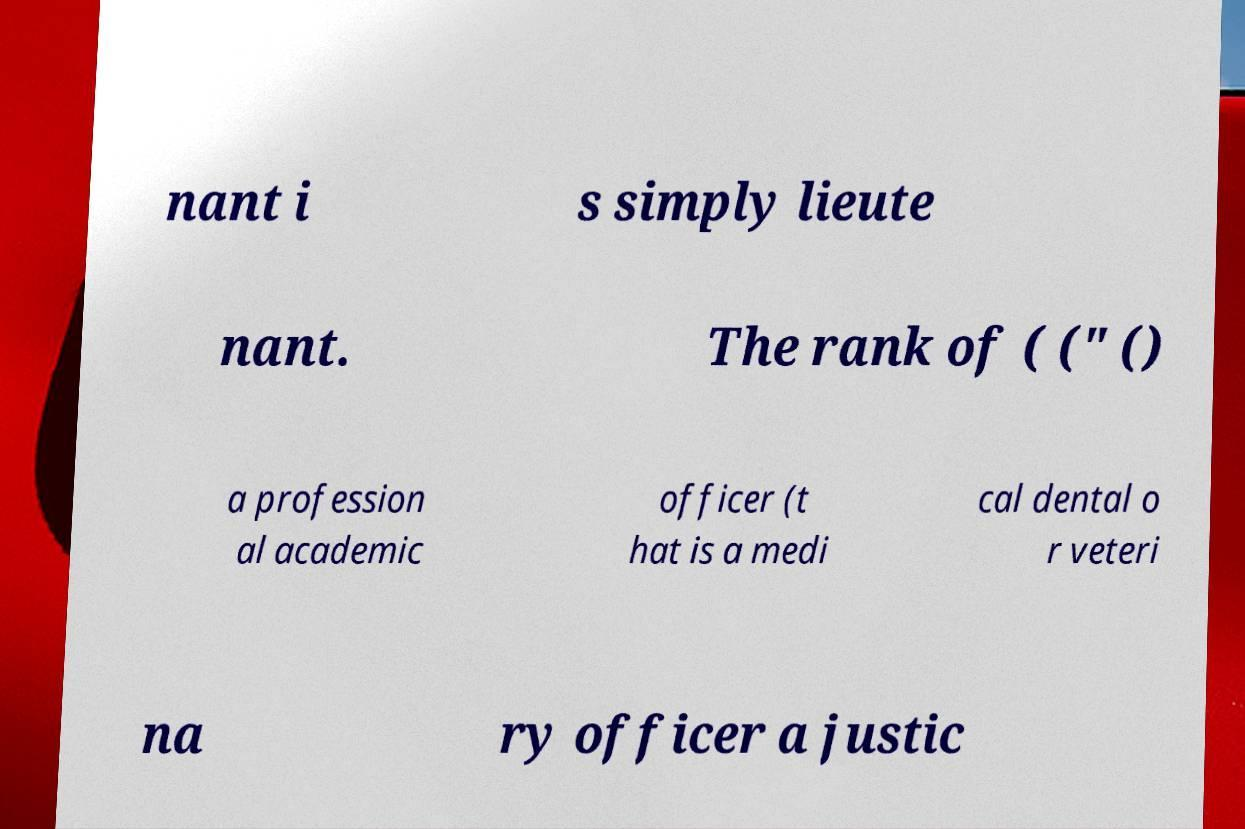Please read and relay the text visible in this image. What does it say? nant i s simply lieute nant. The rank of ( (" () a profession al academic officer (t hat is a medi cal dental o r veteri na ry officer a justic 